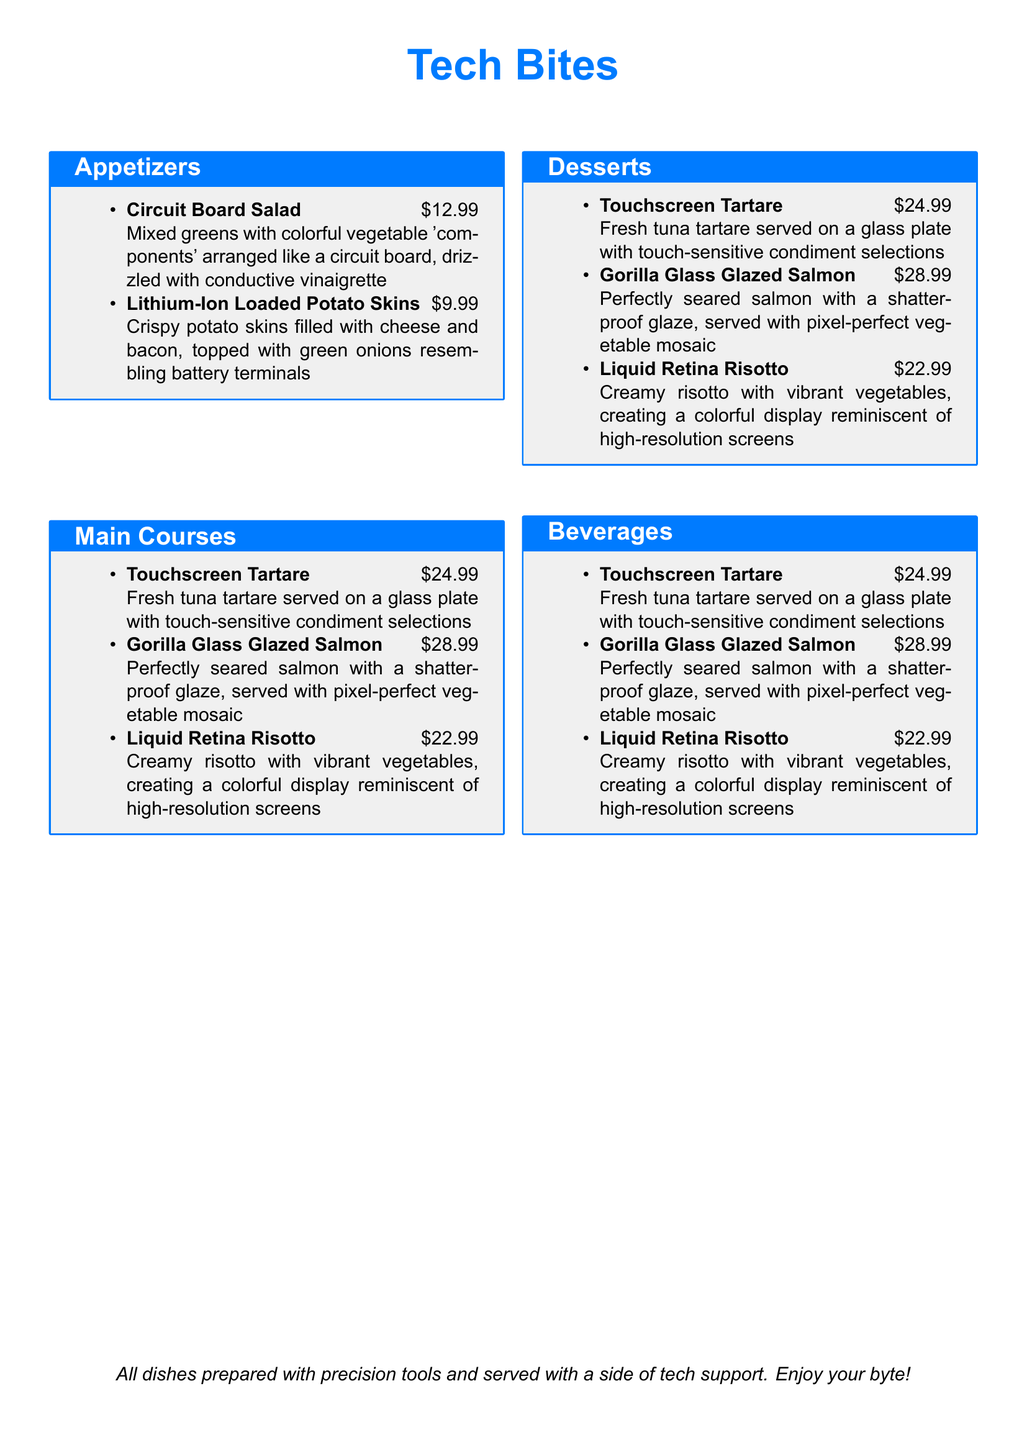What is the name of the appetizer featuring mixed greens? The name of the appetizer is explicitly stated as "Circuit Board Salad."
Answer: Circuit Board Salad How much does the Gorilla Glass Glazed Salmon cost? The cost of the Gorilla Glass Glazed Salmon dish is listed as $28.99.
Answer: $28.99 Which dessert resembles computer memory modules? The dessert resembling computer memory modules is called "RAM Chip Chocolate Cake."
Answer: RAM Chip Chocolate Cake What beverage is served with an LED-lit base? The beverage with an LED-lit base is the "Bluetooth Blueberry Smoothie."
Answer: Bluetooth Blueberry Smoothie Which main course features a colorful vegetable display? The main course that features a colorful vegetable display is "Liquid Retina Risotto."
Answer: Liquid Retina Risotto How many main courses are listed on the menu? The menu lists a total of three main courses.
Answer: Three What is the theme of the restaurant dishes? The theme of the restaurant dishes is inspired by mobile phone components.
Answer: Mobile phone components What is the special note at the bottom of the menu? The special note at the bottom of the menu mentions that all dishes are prepared with precision tools and served with a side of tech support.
Answer: All dishes prepared with precision tools and served with a side of tech support. Enjoy your byte! 